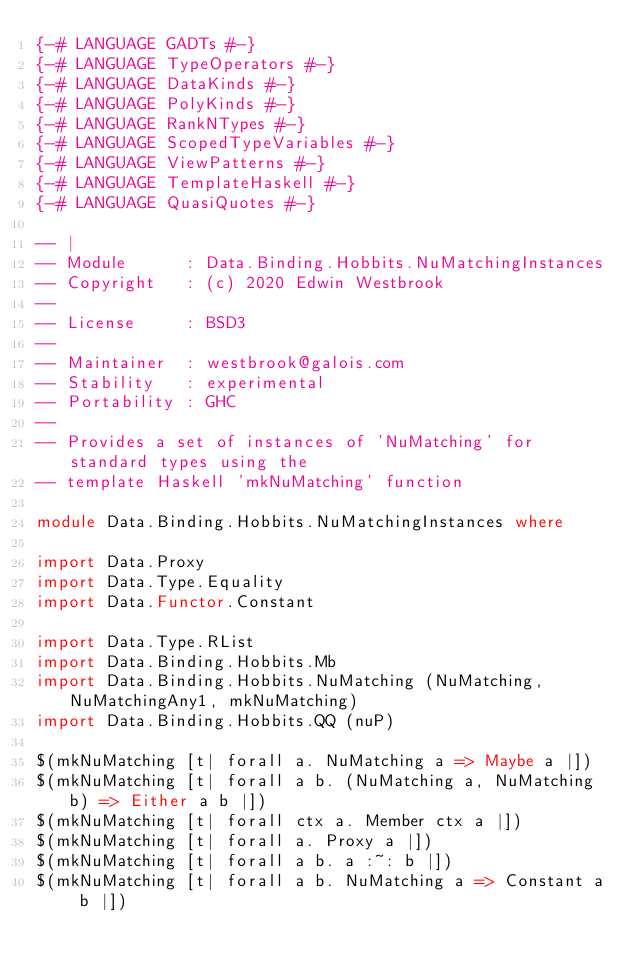<code> <loc_0><loc_0><loc_500><loc_500><_Haskell_>{-# LANGUAGE GADTs #-}
{-# LANGUAGE TypeOperators #-}
{-# LANGUAGE DataKinds #-}
{-# LANGUAGE PolyKinds #-}
{-# LANGUAGE RankNTypes #-}
{-# LANGUAGE ScopedTypeVariables #-}
{-# LANGUAGE ViewPatterns #-}
{-# LANGUAGE TemplateHaskell #-}
{-# LANGUAGE QuasiQuotes #-}

-- |
-- Module      : Data.Binding.Hobbits.NuMatchingInstances
-- Copyright   : (c) 2020 Edwin Westbrook
--
-- License     : BSD3
--
-- Maintainer  : westbrook@galois.com
-- Stability   : experimental
-- Portability : GHC
--
-- Provides a set of instances of 'NuMatching' for standard types using the
-- template Haskell 'mkNuMatching' function

module Data.Binding.Hobbits.NuMatchingInstances where

import Data.Proxy
import Data.Type.Equality
import Data.Functor.Constant

import Data.Type.RList
import Data.Binding.Hobbits.Mb
import Data.Binding.Hobbits.NuMatching (NuMatching, NuMatchingAny1, mkNuMatching)
import Data.Binding.Hobbits.QQ (nuP)

$(mkNuMatching [t| forall a. NuMatching a => Maybe a |])
$(mkNuMatching [t| forall a b. (NuMatching a, NuMatching b) => Either a b |])
$(mkNuMatching [t| forall ctx a. Member ctx a |])
$(mkNuMatching [t| forall a. Proxy a |])
$(mkNuMatching [t| forall a b. a :~: b |])
$(mkNuMatching [t| forall a b. NuMatching a => Constant a b |])
</code> 